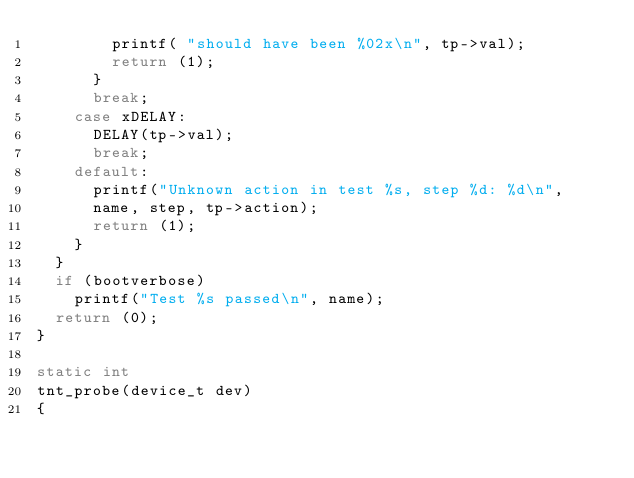Convert code to text. <code><loc_0><loc_0><loc_500><loc_500><_C_>				printf( "should have been %02x\n", tp->val);
				return (1);
			}
			break;
		case xDELAY:
			DELAY(tp->val);
			break;
		default:
			printf("Unknown action in test %s, step %d: %d\n",
			name, step, tp->action);
			return (1);
		}
	}
	if (bootverbose)
		printf("Test %s passed\n", name);
	return (0);
}

static int
tnt_probe(device_t dev)
{
</code> 